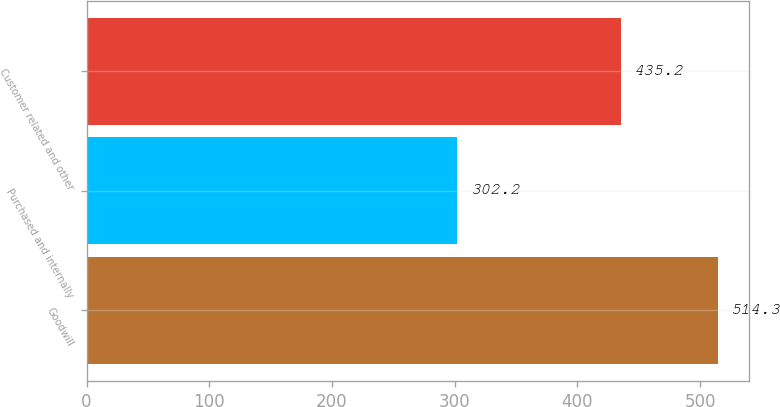Convert chart. <chart><loc_0><loc_0><loc_500><loc_500><bar_chart><fcel>Goodwill<fcel>Purchased and internally<fcel>Customer related and other<nl><fcel>514.3<fcel>302.2<fcel>435.2<nl></chart> 